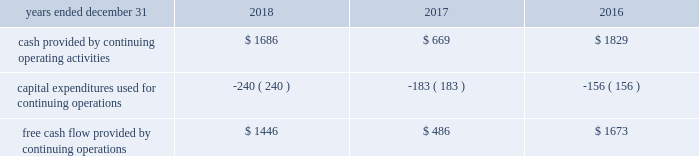( 1 ) adjusted other income ( expense ) excludes pension settlement charges of $ 37 million , $ 128 million , and $ 220 million , for the years ended 2018 , 2017 , and 2016 , respectively .
( 2 ) adjusted items are generally taxed at the estimated annual effective tax rate , except for the applicable tax impact associated with estimated restructuring plan expenses , legacy litigation , accelerated tradename amortization , impairment charges and non-cash pension settlement charges , which are adjusted at the related jurisdictional rates .
In addition , tax expense excludes the tax impacts from the sale of certain assets and liabilities previously classified as held for sale as well as the tax adjustments recorded to finalize the 2017 accounting for the enactment date impact of the tax reform act recorded pursuant torr sab 118 .
( 3 ) adjusted net income from discontinued operations excludes the gain on sale of discontinued operations of $ 82 million , $ 779 million , and $ 0 million for the years ended 2018 , 2017 , and 2016 , respectively .
Adjusted net income from discontinued operations excludes intangible asset amortization of $ 0 million , $ 11rr million , and $ 120 million for the twelve months ended december 31 , 2018 , 2017 , and 2016 , respectively .
The effective tax rate was further adjusted for the applicable tax impact associated with the gain on sale and intangible asset amortization , as applicable .
Free cash flow we use free cash flow , defined as cash flow provided by operations minus capital expenditures , as a non-gaap measure of our core operating performance and cash generating capabilities of our business operations .
This supplemental information related to free cash flow represents a measure not in accordance with u.s .
Gaap and should be viewed in addition to , not instead of , our financial statements .
The use of this non-gaap measure does not imply or represent the residual cash flow for discretionary expenditures .
A reconciliation of this non-gaap measure to cash flow provided by operations is as follows ( in millions ) : .
Impact of foreign currency exchange rate fluctuations we conduct business in more than 120 countries and sovereignties and , because of this , foreign currency exchange rate fluctuations have a significant impact on our business .
Foreign currency exchange rate movements may be significant and may distort true period-to-period comparisons of changes in revenue or pretax income .
Therefore , to give financial statement users meaningful information about our operations , we have provided an illustration of the impact of foreign currency exchange rate fluctuations on our financial results .
The methodology used to calculate this impact isolates the impact of the change in currencies between periods by translating the prior year 2019s revenue , expenses , and net income using the current year 2019s foreign currency exchange rates .
Translating prior year results at current year foreign currency exchange rates , currency fluctuations had a $ 0.08 favorable impact on net income per diluted share during the year ended december 31 , 2018 .
Currency fluctuations had a $ 0.12 favorable impact on net income per diluted share during the year ended december 31 , 2017 , when 2016 results were translated at 2017 rates .
Currency fluctuations had no impact on net income per diluted share during the year ended december 31 , 2016 , when 2015 results were translated at 2016 rates .
Translating prior year results at current year foreign currency exchange rates , currency fluctuations had a $ 0.09 favorable impact on adjusted net income per diluted share during the year ended december 31 , 2018 .
Currency fluctuations had a $ 0.08 favorable impact on adjusted net income per diluted share during the year ended december 31 , 2017 , when 2016 results were translated at 2017 rates .
Currency fluctuations had a $ 0.04 unfavorable impact on adjusted net income per diluted share during the year ended december 31 , 2016 , when 2015 results were translated at 2016 rates .
These translations are performed for comparative purposes only and do not impact the accounting policies or practices for amounts included in the financial statements .
Competition and markets authority the u.k . 2019s competition regulator , the competition and markets authority ( the 201ccma 201d ) , conducted a market investigation into the supply and acquisition of investment consulting and fiduciary management services , including those offered by aon and its competitors in the u.k. , to assess whether any feature or combination of features in the target market prevents , restricts , or distorts competition .
The cma issued a final report on december 12 , 2018 .
The cma will draft a series of orders that will set out the detailed remedies , expected in first quarter of 2019 , when they will be subject to further public consultation .
We do not anticipate the remedies to have a significant impact on the company 2019s consolidated financial position or business .
Financial conduct authority the fca is conducting a market study to assess how effectively competition is working in the wholesale insurance broker sector in the u.k .
In which aon , through its subsidiaries , participates .
The fca has indicated that the purpose of a market study is to assess the extent to which the market is working well in the interests of customers and to identify features of the market that may impact competition .
Depending on the study 2019s findings , the fca may require remedies in order to correct any features found .
What was the average free cash flow provided by continuing operations from 2016 to 2018 in millions? 
Rationale: the average free cash flow provided by continuing operations from 2016 to 2018 was $ 1201.2
Computations: ((((1446 + 486) + 1673) + 3) / 2)
Answer: 1804.0. ( 1 ) adjusted other income ( expense ) excludes pension settlement charges of $ 37 million , $ 128 million , and $ 220 million , for the years ended 2018 , 2017 , and 2016 , respectively .
( 2 ) adjusted items are generally taxed at the estimated annual effective tax rate , except for the applicable tax impact associated with estimated restructuring plan expenses , legacy litigation , accelerated tradename amortization , impairment charges and non-cash pension settlement charges , which are adjusted at the related jurisdictional rates .
In addition , tax expense excludes the tax impacts from the sale of certain assets and liabilities previously classified as held for sale as well as the tax adjustments recorded to finalize the 2017 accounting for the enactment date impact of the tax reform act recorded pursuant torr sab 118 .
( 3 ) adjusted net income from discontinued operations excludes the gain on sale of discontinued operations of $ 82 million , $ 779 million , and $ 0 million for the years ended 2018 , 2017 , and 2016 , respectively .
Adjusted net income from discontinued operations excludes intangible asset amortization of $ 0 million , $ 11rr million , and $ 120 million for the twelve months ended december 31 , 2018 , 2017 , and 2016 , respectively .
The effective tax rate was further adjusted for the applicable tax impact associated with the gain on sale and intangible asset amortization , as applicable .
Free cash flow we use free cash flow , defined as cash flow provided by operations minus capital expenditures , as a non-gaap measure of our core operating performance and cash generating capabilities of our business operations .
This supplemental information related to free cash flow represents a measure not in accordance with u.s .
Gaap and should be viewed in addition to , not instead of , our financial statements .
The use of this non-gaap measure does not imply or represent the residual cash flow for discretionary expenditures .
A reconciliation of this non-gaap measure to cash flow provided by operations is as follows ( in millions ) : .
Impact of foreign currency exchange rate fluctuations we conduct business in more than 120 countries and sovereignties and , because of this , foreign currency exchange rate fluctuations have a significant impact on our business .
Foreign currency exchange rate movements may be significant and may distort true period-to-period comparisons of changes in revenue or pretax income .
Therefore , to give financial statement users meaningful information about our operations , we have provided an illustration of the impact of foreign currency exchange rate fluctuations on our financial results .
The methodology used to calculate this impact isolates the impact of the change in currencies between periods by translating the prior year 2019s revenue , expenses , and net income using the current year 2019s foreign currency exchange rates .
Translating prior year results at current year foreign currency exchange rates , currency fluctuations had a $ 0.08 favorable impact on net income per diluted share during the year ended december 31 , 2018 .
Currency fluctuations had a $ 0.12 favorable impact on net income per diluted share during the year ended december 31 , 2017 , when 2016 results were translated at 2017 rates .
Currency fluctuations had no impact on net income per diluted share during the year ended december 31 , 2016 , when 2015 results were translated at 2016 rates .
Translating prior year results at current year foreign currency exchange rates , currency fluctuations had a $ 0.09 favorable impact on adjusted net income per diluted share during the year ended december 31 , 2018 .
Currency fluctuations had a $ 0.08 favorable impact on adjusted net income per diluted share during the year ended december 31 , 2017 , when 2016 results were translated at 2017 rates .
Currency fluctuations had a $ 0.04 unfavorable impact on adjusted net income per diluted share during the year ended december 31 , 2016 , when 2015 results were translated at 2016 rates .
These translations are performed for comparative purposes only and do not impact the accounting policies or practices for amounts included in the financial statements .
Competition and markets authority the u.k . 2019s competition regulator , the competition and markets authority ( the 201ccma 201d ) , conducted a market investigation into the supply and acquisition of investment consulting and fiduciary management services , including those offered by aon and its competitors in the u.k. , to assess whether any feature or combination of features in the target market prevents , restricts , or distorts competition .
The cma issued a final report on december 12 , 2018 .
The cma will draft a series of orders that will set out the detailed remedies , expected in first quarter of 2019 , when they will be subject to further public consultation .
We do not anticipate the remedies to have a significant impact on the company 2019s consolidated financial position or business .
Financial conduct authority the fca is conducting a market study to assess how effectively competition is working in the wholesale insurance broker sector in the u.k .
In which aon , through its subsidiaries , participates .
The fca has indicated that the purpose of a market study is to assess the extent to which the market is working well in the interests of customers and to identify features of the market that may impact competition .
Depending on the study 2019s findings , the fca may require remedies in order to correct any features found .
What is the decrease observed in the adjusted net income from discontinued operations during 2017 and 2018 , in millions? 
Rationale: it is the difference between those values .
Computations: (779 - 82)
Answer: 697.0. 